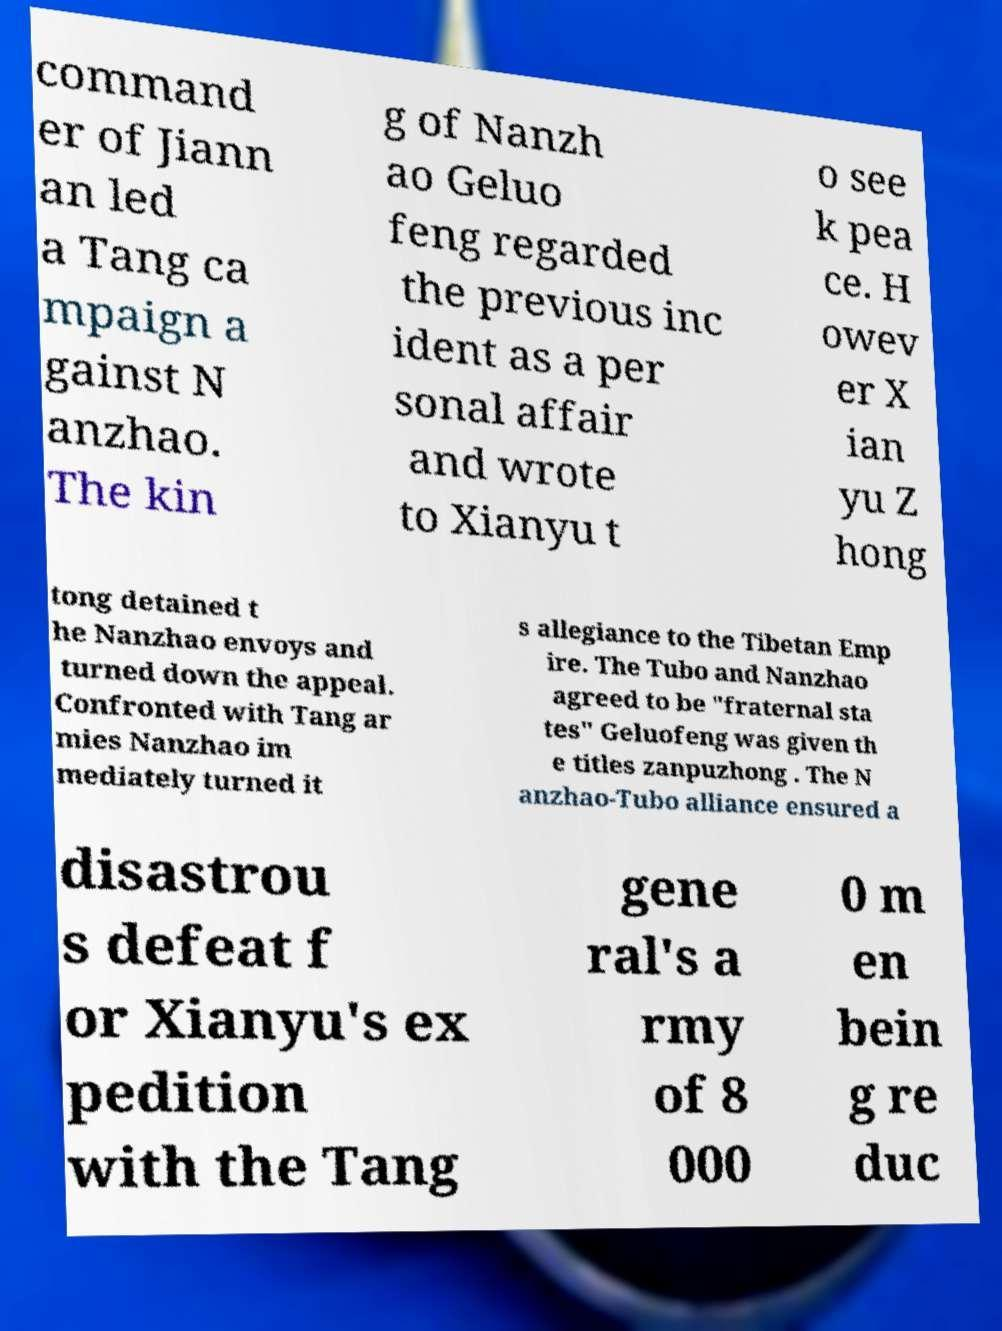Please identify and transcribe the text found in this image. command er of Jiann an led a Tang ca mpaign a gainst N anzhao. The kin g of Nanzh ao Geluo feng regarded the previous inc ident as a per sonal affair and wrote to Xianyu t o see k pea ce. H owev er X ian yu Z hong tong detained t he Nanzhao envoys and turned down the appeal. Confronted with Tang ar mies Nanzhao im mediately turned it s allegiance to the Tibetan Emp ire. The Tubo and Nanzhao agreed to be "fraternal sta tes" Geluofeng was given th e titles zanpuzhong . The N anzhao-Tubo alliance ensured a disastrou s defeat f or Xianyu's ex pedition with the Tang gene ral's a rmy of 8 000 0 m en bein g re duc 